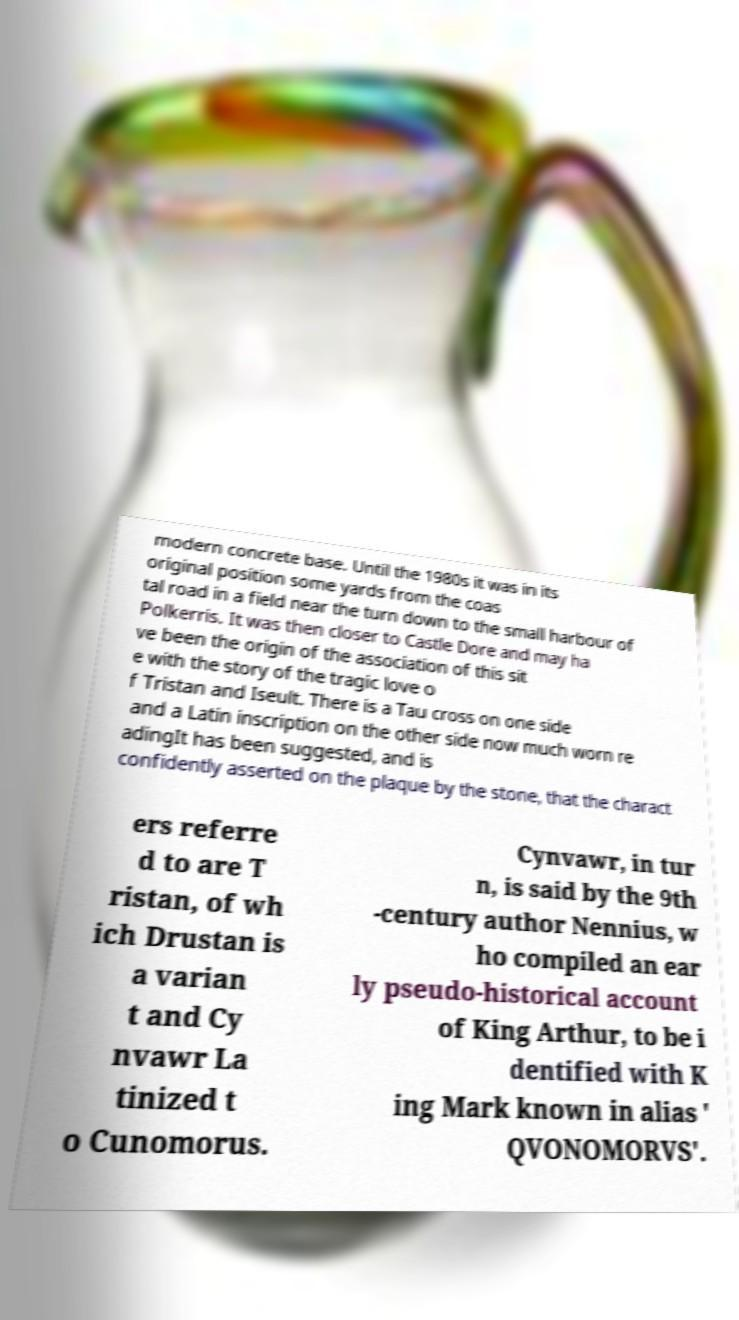Please identify and transcribe the text found in this image. modern concrete base. Until the 1980s it was in its original position some yards from the coas tal road in a field near the turn down to the small harbour of Polkerris. It was then closer to Castle Dore and may ha ve been the origin of the association of this sit e with the story of the tragic love o f Tristan and Iseult. There is a Tau cross on one side and a Latin inscription on the other side now much worn re adingIt has been suggested, and is confidently asserted on the plaque by the stone, that the charact ers referre d to are T ristan, of wh ich Drustan is a varian t and Cy nvawr La tinized t o Cunomorus. Cynvawr, in tur n, is said by the 9th -century author Nennius, w ho compiled an ear ly pseudo-historical account of King Arthur, to be i dentified with K ing Mark known in alias ' QVONOMORVS'. 